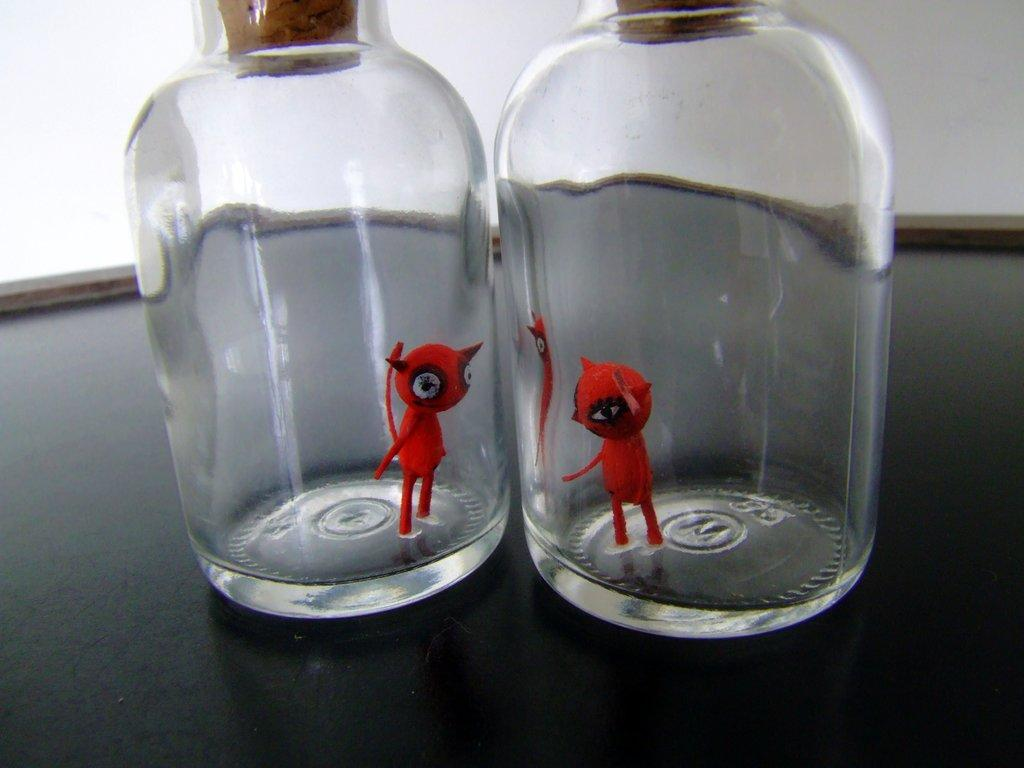What objects are on the table in the image? There are two glass bottles on the table. What is inside the bottles? There are two red toys in the bottles. How are the bottles sealed? Each bottle has a brown cork fitted to the top. What type of shade is provided by the red toys in the image? There is no shade provided by the red toys in the image, as they are inside the glass bottles. 